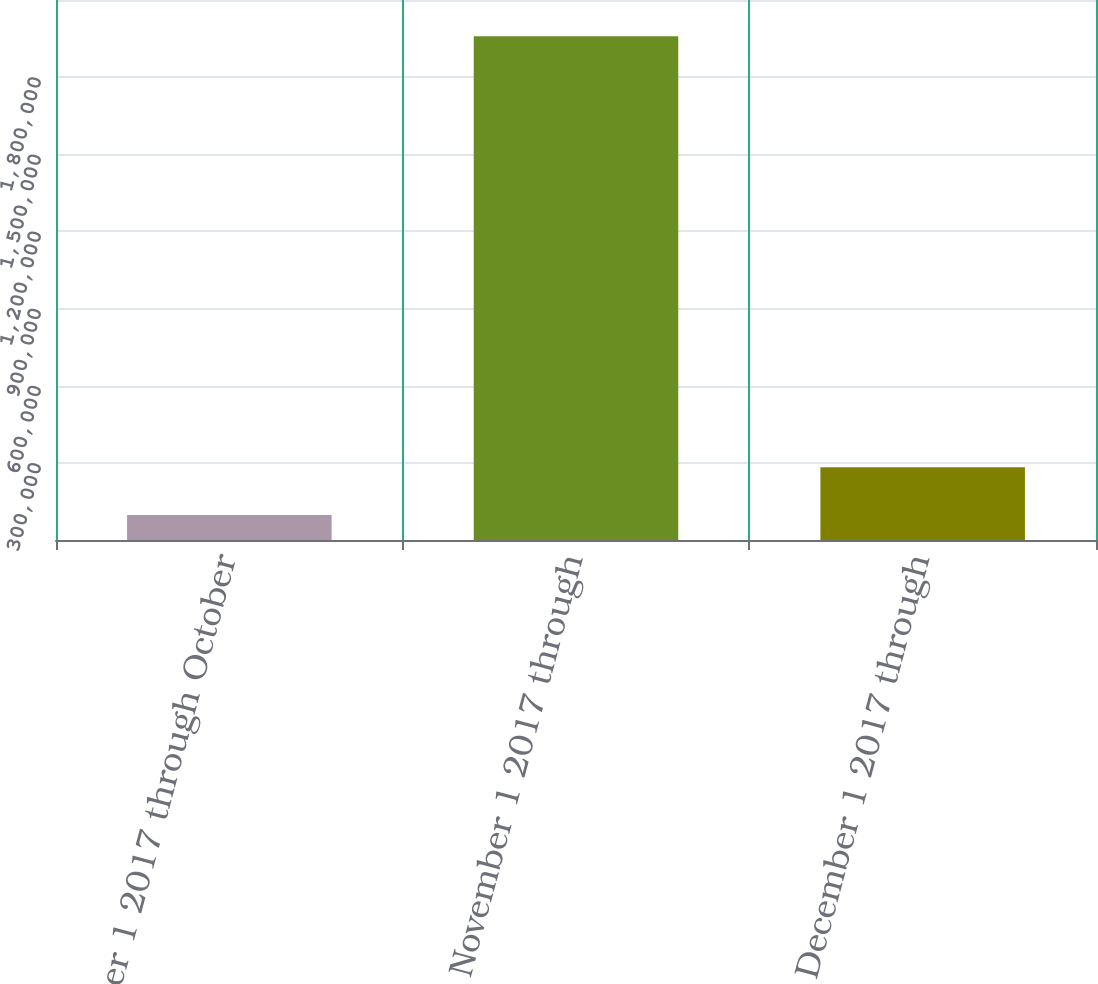<chart> <loc_0><loc_0><loc_500><loc_500><bar_chart><fcel>October 1 2017 through October<fcel>November 1 2017 through<fcel>December 1 2017 through<nl><fcel>96777<fcel>1.95882e+06<fcel>282981<nl></chart> 